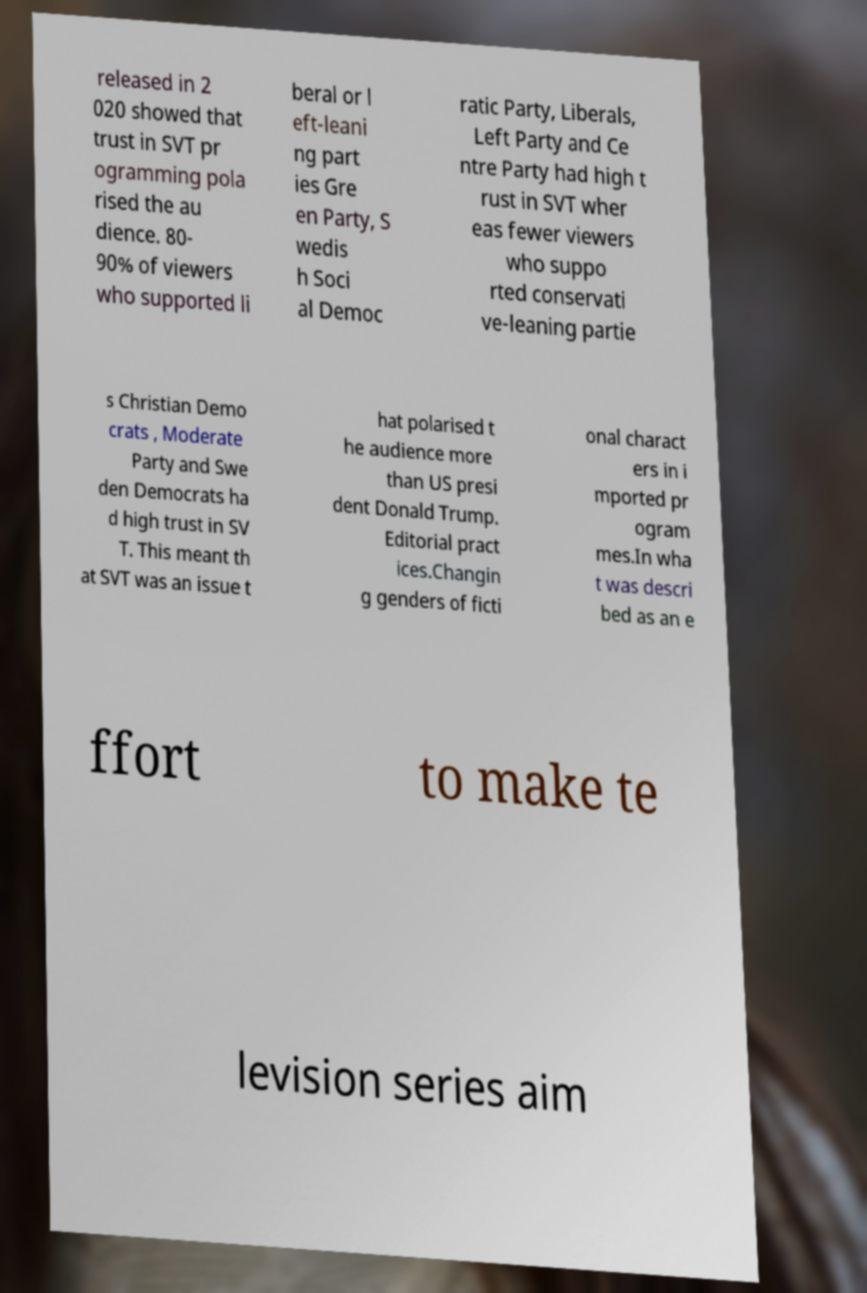Can you accurately transcribe the text from the provided image for me? released in 2 020 showed that trust in SVT pr ogramming pola rised the au dience. 80- 90% of viewers who supported li beral or l eft-leani ng part ies Gre en Party, S wedis h Soci al Democ ratic Party, Liberals, Left Party and Ce ntre Party had high t rust in SVT wher eas fewer viewers who suppo rted conservati ve-leaning partie s Christian Demo crats , Moderate Party and Swe den Democrats ha d high trust in SV T. This meant th at SVT was an issue t hat polarised t he audience more than US presi dent Donald Trump. Editorial pract ices.Changin g genders of ficti onal charact ers in i mported pr ogram mes.In wha t was descri bed as an e ffort to make te levision series aim 